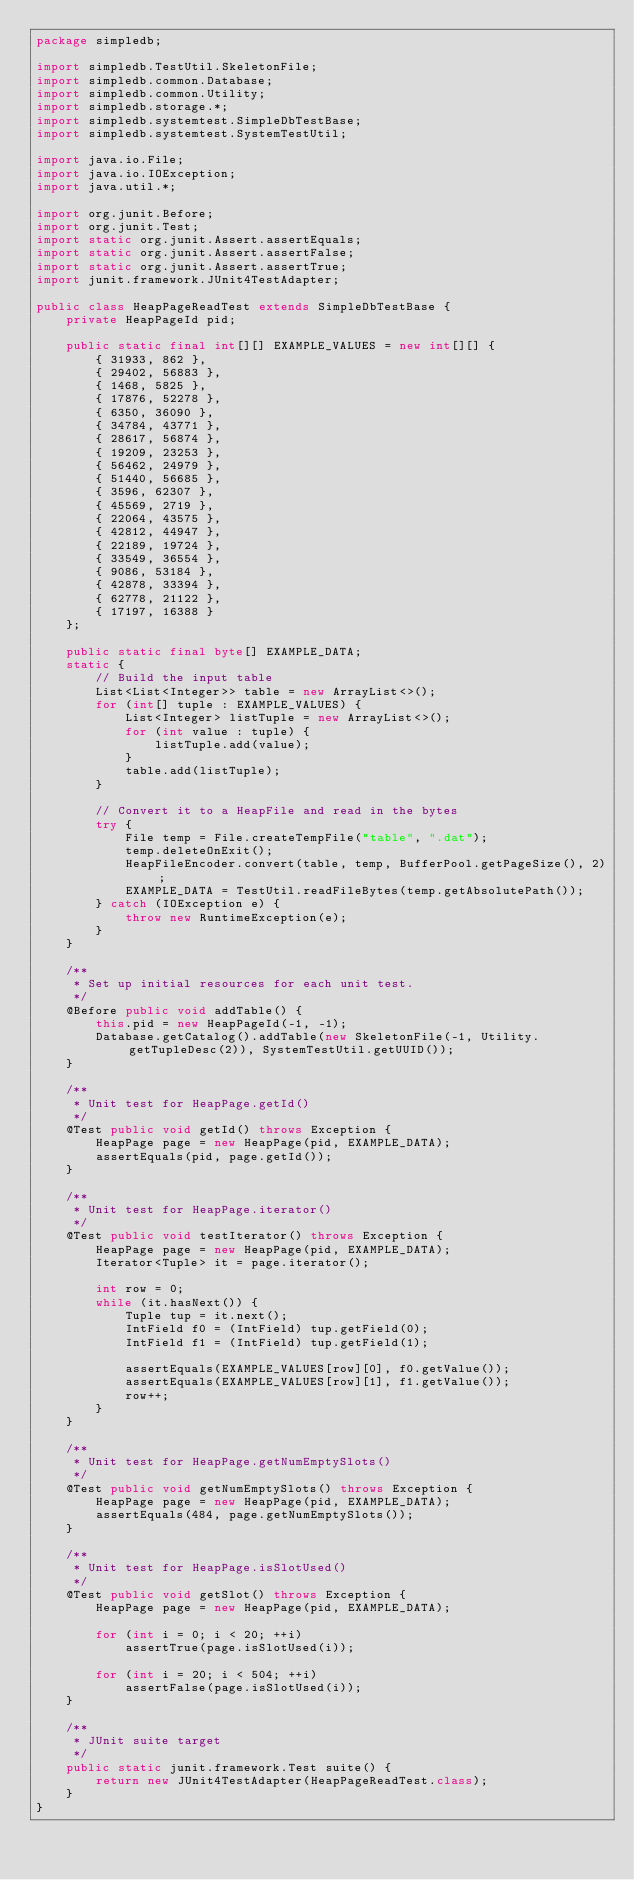<code> <loc_0><loc_0><loc_500><loc_500><_Java_>package simpledb;

import simpledb.TestUtil.SkeletonFile;
import simpledb.common.Database;
import simpledb.common.Utility;
import simpledb.storage.*;
import simpledb.systemtest.SimpleDbTestBase;
import simpledb.systemtest.SystemTestUtil;

import java.io.File;
import java.io.IOException;
import java.util.*;

import org.junit.Before;
import org.junit.Test;
import static org.junit.Assert.assertEquals;
import static org.junit.Assert.assertFalse;
import static org.junit.Assert.assertTrue;
import junit.framework.JUnit4TestAdapter;

public class HeapPageReadTest extends SimpleDbTestBase {
    private HeapPageId pid;

    public static final int[][] EXAMPLE_VALUES = new int[][] {
        { 31933, 862 },
        { 29402, 56883 },
        { 1468, 5825 },
        { 17876, 52278 },
        { 6350, 36090 },
        { 34784, 43771 },
        { 28617, 56874 },
        { 19209, 23253 },
        { 56462, 24979 },
        { 51440, 56685 },
        { 3596, 62307 },
        { 45569, 2719 },
        { 22064, 43575 },
        { 42812, 44947 },
        { 22189, 19724 },
        { 33549, 36554 },
        { 9086, 53184 },
        { 42878, 33394 },
        { 62778, 21122 },
        { 17197, 16388 }
    };

    public static final byte[] EXAMPLE_DATA;
    static {
        // Build the input table
        List<List<Integer>> table = new ArrayList<>();
        for (int[] tuple : EXAMPLE_VALUES) {
            List<Integer> listTuple = new ArrayList<>();
            for (int value : tuple) {
                listTuple.add(value);
            }
            table.add(listTuple);
        }

        // Convert it to a HeapFile and read in the bytes
        try {
            File temp = File.createTempFile("table", ".dat");
            temp.deleteOnExit();
            HeapFileEncoder.convert(table, temp, BufferPool.getPageSize(), 2);
            EXAMPLE_DATA = TestUtil.readFileBytes(temp.getAbsolutePath());
        } catch (IOException e) {
            throw new RuntimeException(e);
        }
    }

    /**
     * Set up initial resources for each unit test.
     */
    @Before public void addTable() {
        this.pid = new HeapPageId(-1, -1);
        Database.getCatalog().addTable(new SkeletonFile(-1, Utility.getTupleDesc(2)), SystemTestUtil.getUUID());
    }

    /**
     * Unit test for HeapPage.getId()
     */
    @Test public void getId() throws Exception {
        HeapPage page = new HeapPage(pid, EXAMPLE_DATA);
        assertEquals(pid, page.getId());
    }

    /**
     * Unit test for HeapPage.iterator()
     */
    @Test public void testIterator() throws Exception {
        HeapPage page = new HeapPage(pid, EXAMPLE_DATA);
        Iterator<Tuple> it = page.iterator();

        int row = 0;
        while (it.hasNext()) {
            Tuple tup = it.next();
            IntField f0 = (IntField) tup.getField(0);
            IntField f1 = (IntField) tup.getField(1);

            assertEquals(EXAMPLE_VALUES[row][0], f0.getValue());
            assertEquals(EXAMPLE_VALUES[row][1], f1.getValue());
            row++;
        }
    }

    /**
     * Unit test for HeapPage.getNumEmptySlots()
     */
    @Test public void getNumEmptySlots() throws Exception {
        HeapPage page = new HeapPage(pid, EXAMPLE_DATA);
        assertEquals(484, page.getNumEmptySlots());
    }

    /**
     * Unit test for HeapPage.isSlotUsed()
     */
    @Test public void getSlot() throws Exception {
        HeapPage page = new HeapPage(pid, EXAMPLE_DATA);

        for (int i = 0; i < 20; ++i)
            assertTrue(page.isSlotUsed(i));

        for (int i = 20; i < 504; ++i)
            assertFalse(page.isSlotUsed(i));
    }

    /**
     * JUnit suite target
     */
    public static junit.framework.Test suite() {
        return new JUnit4TestAdapter(HeapPageReadTest.class);
    }
}
</code> 